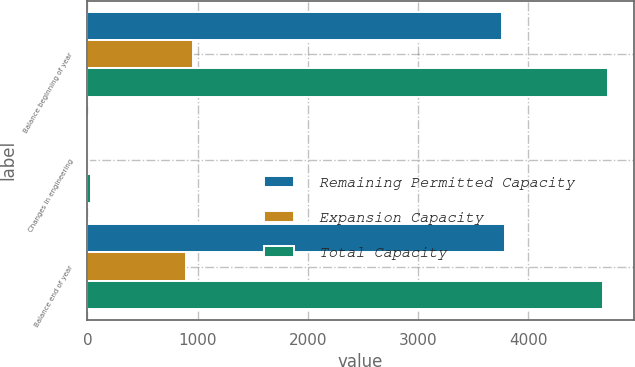Convert chart to OTSL. <chart><loc_0><loc_0><loc_500><loc_500><stacked_bar_chart><ecel><fcel>Balance beginning of year<fcel>Changes in engineering<fcel>Balance end of year<nl><fcel>Remaining Permitted Capacity<fcel>3760<fcel>18<fcel>3787<nl><fcel>Expansion Capacity<fcel>959<fcel>17<fcel>893<nl><fcel>Total Capacity<fcel>4719<fcel>35<fcel>4680<nl></chart> 